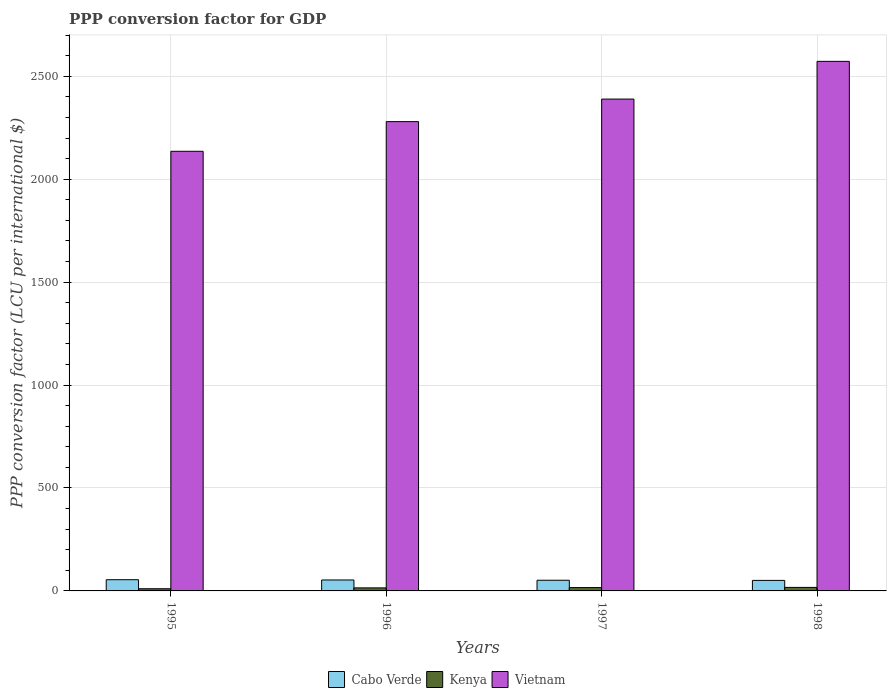How many different coloured bars are there?
Give a very brief answer. 3. How many groups of bars are there?
Keep it short and to the point. 4. Are the number of bars per tick equal to the number of legend labels?
Provide a succinct answer. Yes. How many bars are there on the 3rd tick from the left?
Your answer should be very brief. 3. In how many cases, is the number of bars for a given year not equal to the number of legend labels?
Make the answer very short. 0. What is the PPP conversion factor for GDP in Kenya in 1996?
Offer a very short reply. 14.76. Across all years, what is the maximum PPP conversion factor for GDP in Kenya?
Offer a terse response. 17.11. Across all years, what is the minimum PPP conversion factor for GDP in Cabo Verde?
Offer a very short reply. 51.13. In which year was the PPP conversion factor for GDP in Vietnam maximum?
Make the answer very short. 1998. In which year was the PPP conversion factor for GDP in Kenya minimum?
Your answer should be compact. 1995. What is the total PPP conversion factor for GDP in Cabo Verde in the graph?
Provide a succinct answer. 210.62. What is the difference between the PPP conversion factor for GDP in Cabo Verde in 1997 and that in 1998?
Give a very brief answer. 0.73. What is the difference between the PPP conversion factor for GDP in Cabo Verde in 1996 and the PPP conversion factor for GDP in Vietnam in 1995?
Your answer should be very brief. -2082.48. What is the average PPP conversion factor for GDP in Kenya per year?
Keep it short and to the point. 14.66. In the year 1995, what is the difference between the PPP conversion factor for GDP in Cabo Verde and PPP conversion factor for GDP in Vietnam?
Offer a terse response. -2081.21. What is the ratio of the PPP conversion factor for GDP in Vietnam in 1996 to that in 1998?
Your answer should be compact. 0.89. Is the PPP conversion factor for GDP in Cabo Verde in 1997 less than that in 1998?
Provide a short and direct response. No. What is the difference between the highest and the second highest PPP conversion factor for GDP in Kenya?
Provide a succinct answer. 0.94. What is the difference between the highest and the lowest PPP conversion factor for GDP in Vietnam?
Give a very brief answer. 436.87. Is the sum of the PPP conversion factor for GDP in Cabo Verde in 1995 and 1996 greater than the maximum PPP conversion factor for GDP in Vietnam across all years?
Provide a short and direct response. No. What does the 1st bar from the left in 1998 represents?
Your answer should be very brief. Cabo Verde. What does the 1st bar from the right in 1996 represents?
Provide a succinct answer. Vietnam. What is the difference between two consecutive major ticks on the Y-axis?
Provide a succinct answer. 500. Are the values on the major ticks of Y-axis written in scientific E-notation?
Make the answer very short. No. Does the graph contain grids?
Make the answer very short. Yes. What is the title of the graph?
Your answer should be compact. PPP conversion factor for GDP. Does "China" appear as one of the legend labels in the graph?
Keep it short and to the point. No. What is the label or title of the Y-axis?
Ensure brevity in your answer.  PPP conversion factor (LCU per international $). What is the PPP conversion factor (LCU per international $) of Cabo Verde in 1995?
Give a very brief answer. 54.46. What is the PPP conversion factor (LCU per international $) in Kenya in 1995?
Ensure brevity in your answer.  10.59. What is the PPP conversion factor (LCU per international $) in Vietnam in 1995?
Provide a short and direct response. 2135.67. What is the PPP conversion factor (LCU per international $) in Cabo Verde in 1996?
Ensure brevity in your answer.  53.19. What is the PPP conversion factor (LCU per international $) of Kenya in 1996?
Your answer should be compact. 14.76. What is the PPP conversion factor (LCU per international $) of Vietnam in 1996?
Provide a short and direct response. 2279.78. What is the PPP conversion factor (LCU per international $) of Cabo Verde in 1997?
Your answer should be compact. 51.86. What is the PPP conversion factor (LCU per international $) of Kenya in 1997?
Offer a very short reply. 16.17. What is the PPP conversion factor (LCU per international $) in Vietnam in 1997?
Give a very brief answer. 2389.3. What is the PPP conversion factor (LCU per international $) of Cabo Verde in 1998?
Provide a succinct answer. 51.13. What is the PPP conversion factor (LCU per international $) of Kenya in 1998?
Your response must be concise. 17.11. What is the PPP conversion factor (LCU per international $) in Vietnam in 1998?
Your answer should be compact. 2572.54. Across all years, what is the maximum PPP conversion factor (LCU per international $) in Cabo Verde?
Your answer should be very brief. 54.46. Across all years, what is the maximum PPP conversion factor (LCU per international $) in Kenya?
Make the answer very short. 17.11. Across all years, what is the maximum PPP conversion factor (LCU per international $) in Vietnam?
Your answer should be compact. 2572.54. Across all years, what is the minimum PPP conversion factor (LCU per international $) of Cabo Verde?
Give a very brief answer. 51.13. Across all years, what is the minimum PPP conversion factor (LCU per international $) of Kenya?
Provide a succinct answer. 10.59. Across all years, what is the minimum PPP conversion factor (LCU per international $) in Vietnam?
Offer a very short reply. 2135.67. What is the total PPP conversion factor (LCU per international $) in Cabo Verde in the graph?
Offer a terse response. 210.62. What is the total PPP conversion factor (LCU per international $) of Kenya in the graph?
Keep it short and to the point. 58.63. What is the total PPP conversion factor (LCU per international $) of Vietnam in the graph?
Make the answer very short. 9377.29. What is the difference between the PPP conversion factor (LCU per international $) in Cabo Verde in 1995 and that in 1996?
Offer a very short reply. 1.27. What is the difference between the PPP conversion factor (LCU per international $) of Kenya in 1995 and that in 1996?
Offer a terse response. -4.18. What is the difference between the PPP conversion factor (LCU per international $) in Vietnam in 1995 and that in 1996?
Keep it short and to the point. -144.12. What is the difference between the PPP conversion factor (LCU per international $) of Cabo Verde in 1995 and that in 1997?
Provide a short and direct response. 2.6. What is the difference between the PPP conversion factor (LCU per international $) of Kenya in 1995 and that in 1997?
Offer a very short reply. -5.59. What is the difference between the PPP conversion factor (LCU per international $) of Vietnam in 1995 and that in 1997?
Keep it short and to the point. -253.63. What is the difference between the PPP conversion factor (LCU per international $) of Cabo Verde in 1995 and that in 1998?
Offer a terse response. 3.33. What is the difference between the PPP conversion factor (LCU per international $) in Kenya in 1995 and that in 1998?
Keep it short and to the point. -6.52. What is the difference between the PPP conversion factor (LCU per international $) of Vietnam in 1995 and that in 1998?
Give a very brief answer. -436.87. What is the difference between the PPP conversion factor (LCU per international $) of Cabo Verde in 1996 and that in 1997?
Provide a succinct answer. 1.33. What is the difference between the PPP conversion factor (LCU per international $) in Kenya in 1996 and that in 1997?
Provide a short and direct response. -1.41. What is the difference between the PPP conversion factor (LCU per international $) in Vietnam in 1996 and that in 1997?
Make the answer very short. -109.51. What is the difference between the PPP conversion factor (LCU per international $) in Cabo Verde in 1996 and that in 1998?
Give a very brief answer. 2.06. What is the difference between the PPP conversion factor (LCU per international $) in Kenya in 1996 and that in 1998?
Keep it short and to the point. -2.35. What is the difference between the PPP conversion factor (LCU per international $) in Vietnam in 1996 and that in 1998?
Offer a terse response. -292.76. What is the difference between the PPP conversion factor (LCU per international $) of Cabo Verde in 1997 and that in 1998?
Your response must be concise. 0.73. What is the difference between the PPP conversion factor (LCU per international $) of Kenya in 1997 and that in 1998?
Give a very brief answer. -0.94. What is the difference between the PPP conversion factor (LCU per international $) in Vietnam in 1997 and that in 1998?
Your answer should be compact. -183.24. What is the difference between the PPP conversion factor (LCU per international $) in Cabo Verde in 1995 and the PPP conversion factor (LCU per international $) in Kenya in 1996?
Your answer should be compact. 39.69. What is the difference between the PPP conversion factor (LCU per international $) in Cabo Verde in 1995 and the PPP conversion factor (LCU per international $) in Vietnam in 1996?
Ensure brevity in your answer.  -2225.33. What is the difference between the PPP conversion factor (LCU per international $) of Kenya in 1995 and the PPP conversion factor (LCU per international $) of Vietnam in 1996?
Keep it short and to the point. -2269.2. What is the difference between the PPP conversion factor (LCU per international $) of Cabo Verde in 1995 and the PPP conversion factor (LCU per international $) of Kenya in 1997?
Offer a very short reply. 38.28. What is the difference between the PPP conversion factor (LCU per international $) in Cabo Verde in 1995 and the PPP conversion factor (LCU per international $) in Vietnam in 1997?
Your answer should be compact. -2334.84. What is the difference between the PPP conversion factor (LCU per international $) in Kenya in 1995 and the PPP conversion factor (LCU per international $) in Vietnam in 1997?
Provide a short and direct response. -2378.71. What is the difference between the PPP conversion factor (LCU per international $) of Cabo Verde in 1995 and the PPP conversion factor (LCU per international $) of Kenya in 1998?
Keep it short and to the point. 37.35. What is the difference between the PPP conversion factor (LCU per international $) of Cabo Verde in 1995 and the PPP conversion factor (LCU per international $) of Vietnam in 1998?
Make the answer very short. -2518.09. What is the difference between the PPP conversion factor (LCU per international $) of Kenya in 1995 and the PPP conversion factor (LCU per international $) of Vietnam in 1998?
Offer a very short reply. -2561.96. What is the difference between the PPP conversion factor (LCU per international $) in Cabo Verde in 1996 and the PPP conversion factor (LCU per international $) in Kenya in 1997?
Give a very brief answer. 37.01. What is the difference between the PPP conversion factor (LCU per international $) in Cabo Verde in 1996 and the PPP conversion factor (LCU per international $) in Vietnam in 1997?
Make the answer very short. -2336.11. What is the difference between the PPP conversion factor (LCU per international $) of Kenya in 1996 and the PPP conversion factor (LCU per international $) of Vietnam in 1997?
Offer a very short reply. -2374.54. What is the difference between the PPP conversion factor (LCU per international $) of Cabo Verde in 1996 and the PPP conversion factor (LCU per international $) of Kenya in 1998?
Ensure brevity in your answer.  36.08. What is the difference between the PPP conversion factor (LCU per international $) in Cabo Verde in 1996 and the PPP conversion factor (LCU per international $) in Vietnam in 1998?
Provide a short and direct response. -2519.35. What is the difference between the PPP conversion factor (LCU per international $) of Kenya in 1996 and the PPP conversion factor (LCU per international $) of Vietnam in 1998?
Provide a succinct answer. -2557.78. What is the difference between the PPP conversion factor (LCU per international $) of Cabo Verde in 1997 and the PPP conversion factor (LCU per international $) of Kenya in 1998?
Your response must be concise. 34.75. What is the difference between the PPP conversion factor (LCU per international $) of Cabo Verde in 1997 and the PPP conversion factor (LCU per international $) of Vietnam in 1998?
Your response must be concise. -2520.69. What is the difference between the PPP conversion factor (LCU per international $) in Kenya in 1997 and the PPP conversion factor (LCU per international $) in Vietnam in 1998?
Your answer should be very brief. -2556.37. What is the average PPP conversion factor (LCU per international $) in Cabo Verde per year?
Provide a short and direct response. 52.66. What is the average PPP conversion factor (LCU per international $) in Kenya per year?
Offer a terse response. 14.66. What is the average PPP conversion factor (LCU per international $) of Vietnam per year?
Your response must be concise. 2344.32. In the year 1995, what is the difference between the PPP conversion factor (LCU per international $) of Cabo Verde and PPP conversion factor (LCU per international $) of Kenya?
Keep it short and to the point. 43.87. In the year 1995, what is the difference between the PPP conversion factor (LCU per international $) of Cabo Verde and PPP conversion factor (LCU per international $) of Vietnam?
Provide a short and direct response. -2081.21. In the year 1995, what is the difference between the PPP conversion factor (LCU per international $) of Kenya and PPP conversion factor (LCU per international $) of Vietnam?
Provide a succinct answer. -2125.08. In the year 1996, what is the difference between the PPP conversion factor (LCU per international $) of Cabo Verde and PPP conversion factor (LCU per international $) of Kenya?
Offer a very short reply. 38.43. In the year 1996, what is the difference between the PPP conversion factor (LCU per international $) of Cabo Verde and PPP conversion factor (LCU per international $) of Vietnam?
Ensure brevity in your answer.  -2226.6. In the year 1996, what is the difference between the PPP conversion factor (LCU per international $) of Kenya and PPP conversion factor (LCU per international $) of Vietnam?
Make the answer very short. -2265.02. In the year 1997, what is the difference between the PPP conversion factor (LCU per international $) in Cabo Verde and PPP conversion factor (LCU per international $) in Kenya?
Provide a short and direct response. 35.68. In the year 1997, what is the difference between the PPP conversion factor (LCU per international $) in Cabo Verde and PPP conversion factor (LCU per international $) in Vietnam?
Your answer should be very brief. -2337.44. In the year 1997, what is the difference between the PPP conversion factor (LCU per international $) of Kenya and PPP conversion factor (LCU per international $) of Vietnam?
Your answer should be very brief. -2373.13. In the year 1998, what is the difference between the PPP conversion factor (LCU per international $) of Cabo Verde and PPP conversion factor (LCU per international $) of Kenya?
Your answer should be compact. 34.02. In the year 1998, what is the difference between the PPP conversion factor (LCU per international $) in Cabo Verde and PPP conversion factor (LCU per international $) in Vietnam?
Offer a very short reply. -2521.42. In the year 1998, what is the difference between the PPP conversion factor (LCU per international $) in Kenya and PPP conversion factor (LCU per international $) in Vietnam?
Make the answer very short. -2555.43. What is the ratio of the PPP conversion factor (LCU per international $) of Cabo Verde in 1995 to that in 1996?
Offer a very short reply. 1.02. What is the ratio of the PPP conversion factor (LCU per international $) of Kenya in 1995 to that in 1996?
Your answer should be very brief. 0.72. What is the ratio of the PPP conversion factor (LCU per international $) of Vietnam in 1995 to that in 1996?
Offer a very short reply. 0.94. What is the ratio of the PPP conversion factor (LCU per international $) in Cabo Verde in 1995 to that in 1997?
Ensure brevity in your answer.  1.05. What is the ratio of the PPP conversion factor (LCU per international $) of Kenya in 1995 to that in 1997?
Offer a very short reply. 0.65. What is the ratio of the PPP conversion factor (LCU per international $) of Vietnam in 1995 to that in 1997?
Your answer should be compact. 0.89. What is the ratio of the PPP conversion factor (LCU per international $) of Cabo Verde in 1995 to that in 1998?
Your answer should be compact. 1.07. What is the ratio of the PPP conversion factor (LCU per international $) in Kenya in 1995 to that in 1998?
Offer a very short reply. 0.62. What is the ratio of the PPP conversion factor (LCU per international $) of Vietnam in 1995 to that in 1998?
Keep it short and to the point. 0.83. What is the ratio of the PPP conversion factor (LCU per international $) in Cabo Verde in 1996 to that in 1997?
Your answer should be very brief. 1.03. What is the ratio of the PPP conversion factor (LCU per international $) in Kenya in 1996 to that in 1997?
Your answer should be very brief. 0.91. What is the ratio of the PPP conversion factor (LCU per international $) in Vietnam in 1996 to that in 1997?
Provide a short and direct response. 0.95. What is the ratio of the PPP conversion factor (LCU per international $) of Cabo Verde in 1996 to that in 1998?
Provide a succinct answer. 1.04. What is the ratio of the PPP conversion factor (LCU per international $) of Kenya in 1996 to that in 1998?
Your answer should be very brief. 0.86. What is the ratio of the PPP conversion factor (LCU per international $) in Vietnam in 1996 to that in 1998?
Offer a terse response. 0.89. What is the ratio of the PPP conversion factor (LCU per international $) of Cabo Verde in 1997 to that in 1998?
Ensure brevity in your answer.  1.01. What is the ratio of the PPP conversion factor (LCU per international $) in Kenya in 1997 to that in 1998?
Keep it short and to the point. 0.95. What is the ratio of the PPP conversion factor (LCU per international $) of Vietnam in 1997 to that in 1998?
Ensure brevity in your answer.  0.93. What is the difference between the highest and the second highest PPP conversion factor (LCU per international $) in Cabo Verde?
Your response must be concise. 1.27. What is the difference between the highest and the second highest PPP conversion factor (LCU per international $) in Kenya?
Keep it short and to the point. 0.94. What is the difference between the highest and the second highest PPP conversion factor (LCU per international $) in Vietnam?
Offer a terse response. 183.24. What is the difference between the highest and the lowest PPP conversion factor (LCU per international $) in Cabo Verde?
Make the answer very short. 3.33. What is the difference between the highest and the lowest PPP conversion factor (LCU per international $) of Kenya?
Provide a succinct answer. 6.52. What is the difference between the highest and the lowest PPP conversion factor (LCU per international $) of Vietnam?
Provide a short and direct response. 436.87. 